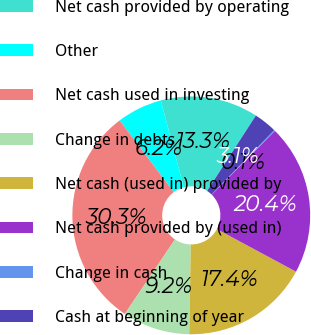Convert chart to OTSL. <chart><loc_0><loc_0><loc_500><loc_500><pie_chart><fcel>Net cash provided by operating<fcel>Other<fcel>Net cash used in investing<fcel>Change in debts<fcel>Net cash (used in) provided by<fcel>Net cash provided by (used in)<fcel>Change in cash<fcel>Cash at beginning of year<nl><fcel>13.27%<fcel>6.16%<fcel>30.27%<fcel>9.17%<fcel>17.42%<fcel>20.44%<fcel>0.13%<fcel>3.14%<nl></chart> 